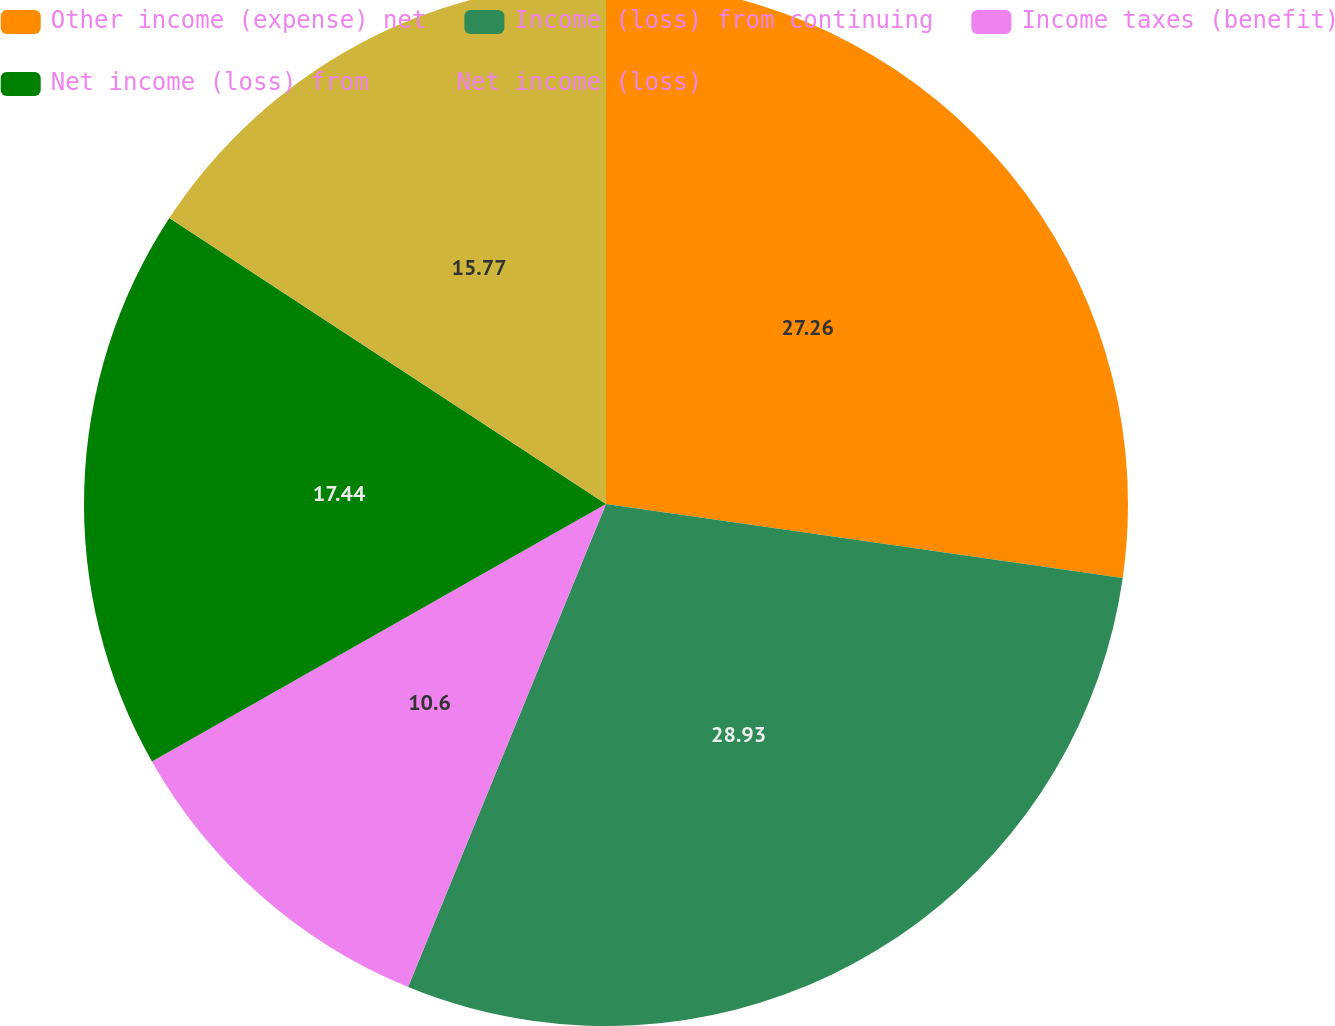Convert chart. <chart><loc_0><loc_0><loc_500><loc_500><pie_chart><fcel>Other income (expense) net<fcel>Income (loss) from continuing<fcel>Income taxes (benefit)<fcel>Net income (loss) from<fcel>Net income (loss)<nl><fcel>27.26%<fcel>28.93%<fcel>10.6%<fcel>17.44%<fcel>15.77%<nl></chart> 